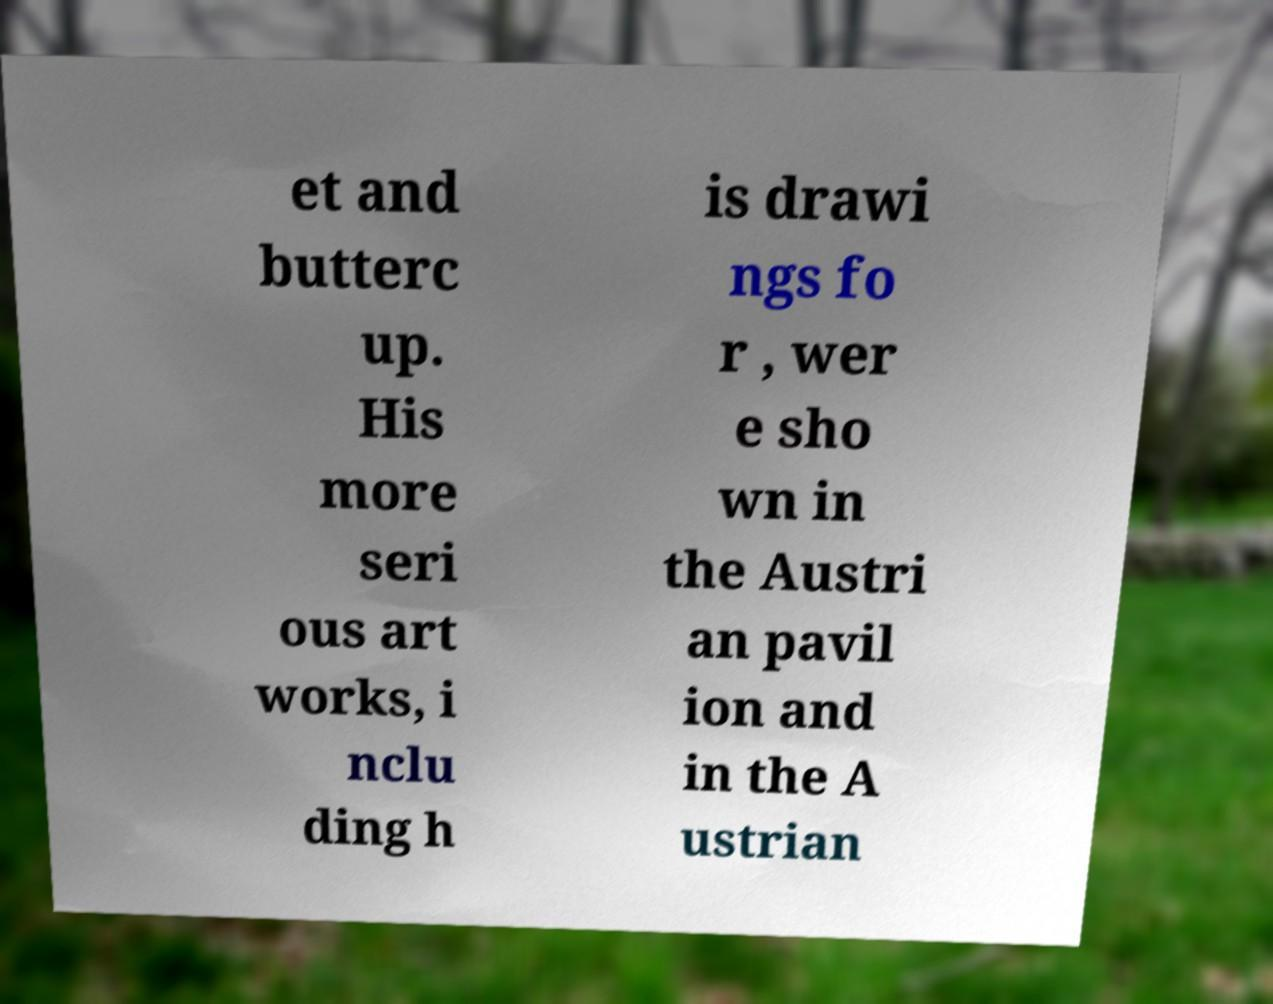Can you read and provide the text displayed in the image?This photo seems to have some interesting text. Can you extract and type it out for me? et and butterc up. His more seri ous art works, i nclu ding h is drawi ngs fo r , wer e sho wn in the Austri an pavil ion and in the A ustrian 